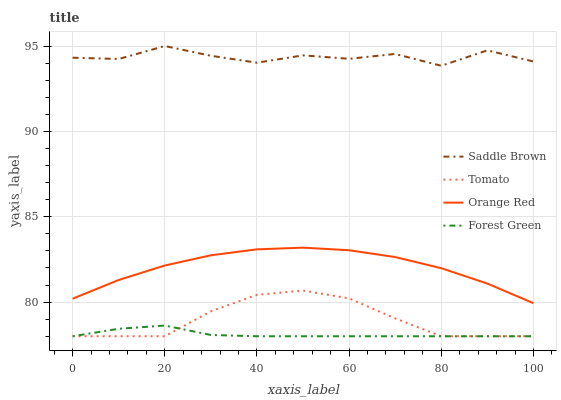Does Forest Green have the minimum area under the curve?
Answer yes or no. Yes. Does Saddle Brown have the maximum area under the curve?
Answer yes or no. Yes. Does Saddle Brown have the minimum area under the curve?
Answer yes or no. No. Does Forest Green have the maximum area under the curve?
Answer yes or no. No. Is Forest Green the smoothest?
Answer yes or no. Yes. Is Saddle Brown the roughest?
Answer yes or no. Yes. Is Saddle Brown the smoothest?
Answer yes or no. No. Is Forest Green the roughest?
Answer yes or no. No. Does Tomato have the lowest value?
Answer yes or no. Yes. Does Saddle Brown have the lowest value?
Answer yes or no. No. Does Saddle Brown have the highest value?
Answer yes or no. Yes. Does Forest Green have the highest value?
Answer yes or no. No. Is Orange Red less than Saddle Brown?
Answer yes or no. Yes. Is Orange Red greater than Forest Green?
Answer yes or no. Yes. Does Forest Green intersect Tomato?
Answer yes or no. Yes. Is Forest Green less than Tomato?
Answer yes or no. No. Is Forest Green greater than Tomato?
Answer yes or no. No. Does Orange Red intersect Saddle Brown?
Answer yes or no. No. 